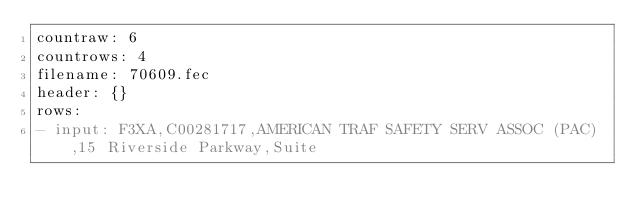<code> <loc_0><loc_0><loc_500><loc_500><_YAML_>countraw: 6
countrows: 4
filename: 70609.fec
header: {}
rows:
- input: F3XA,C00281717,AMERICAN TRAF SAFETY SERV ASSOC (PAC),15 Riverside Parkway,Suite</code> 